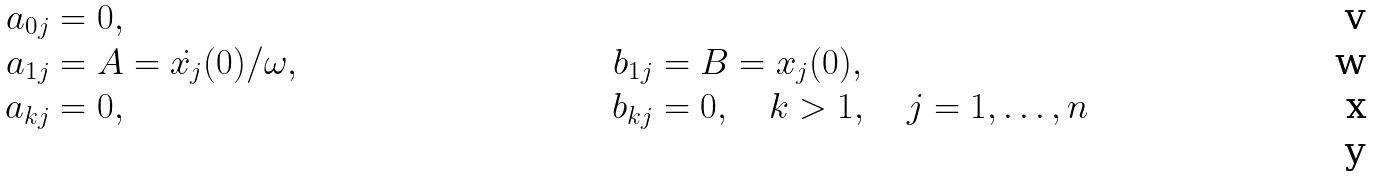<formula> <loc_0><loc_0><loc_500><loc_500>a _ { 0 j } & = 0 , \\ a _ { 1 j } & = A = \dot { x _ { j } } ( 0 ) / \omega , \quad & b _ { 1 j } & = B = x _ { j } ( 0 ) , \\ a _ { k j } & = 0 , \quad & b _ { k j } & = 0 , \quad k > 1 , \quad j = 1 , \dots , n \\</formula> 